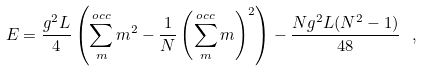<formula> <loc_0><loc_0><loc_500><loc_500>E = \frac { g ^ { 2 } L } { 4 } \left ( \sum _ { m } ^ { o c c } m ^ { 2 } - \frac { 1 } { N } \left ( \sum _ { m } ^ { o c c } m \right ) ^ { 2 } \right ) - \frac { N g ^ { 2 } L ( N ^ { 2 } - 1 ) } { 4 8 } \ ,</formula> 